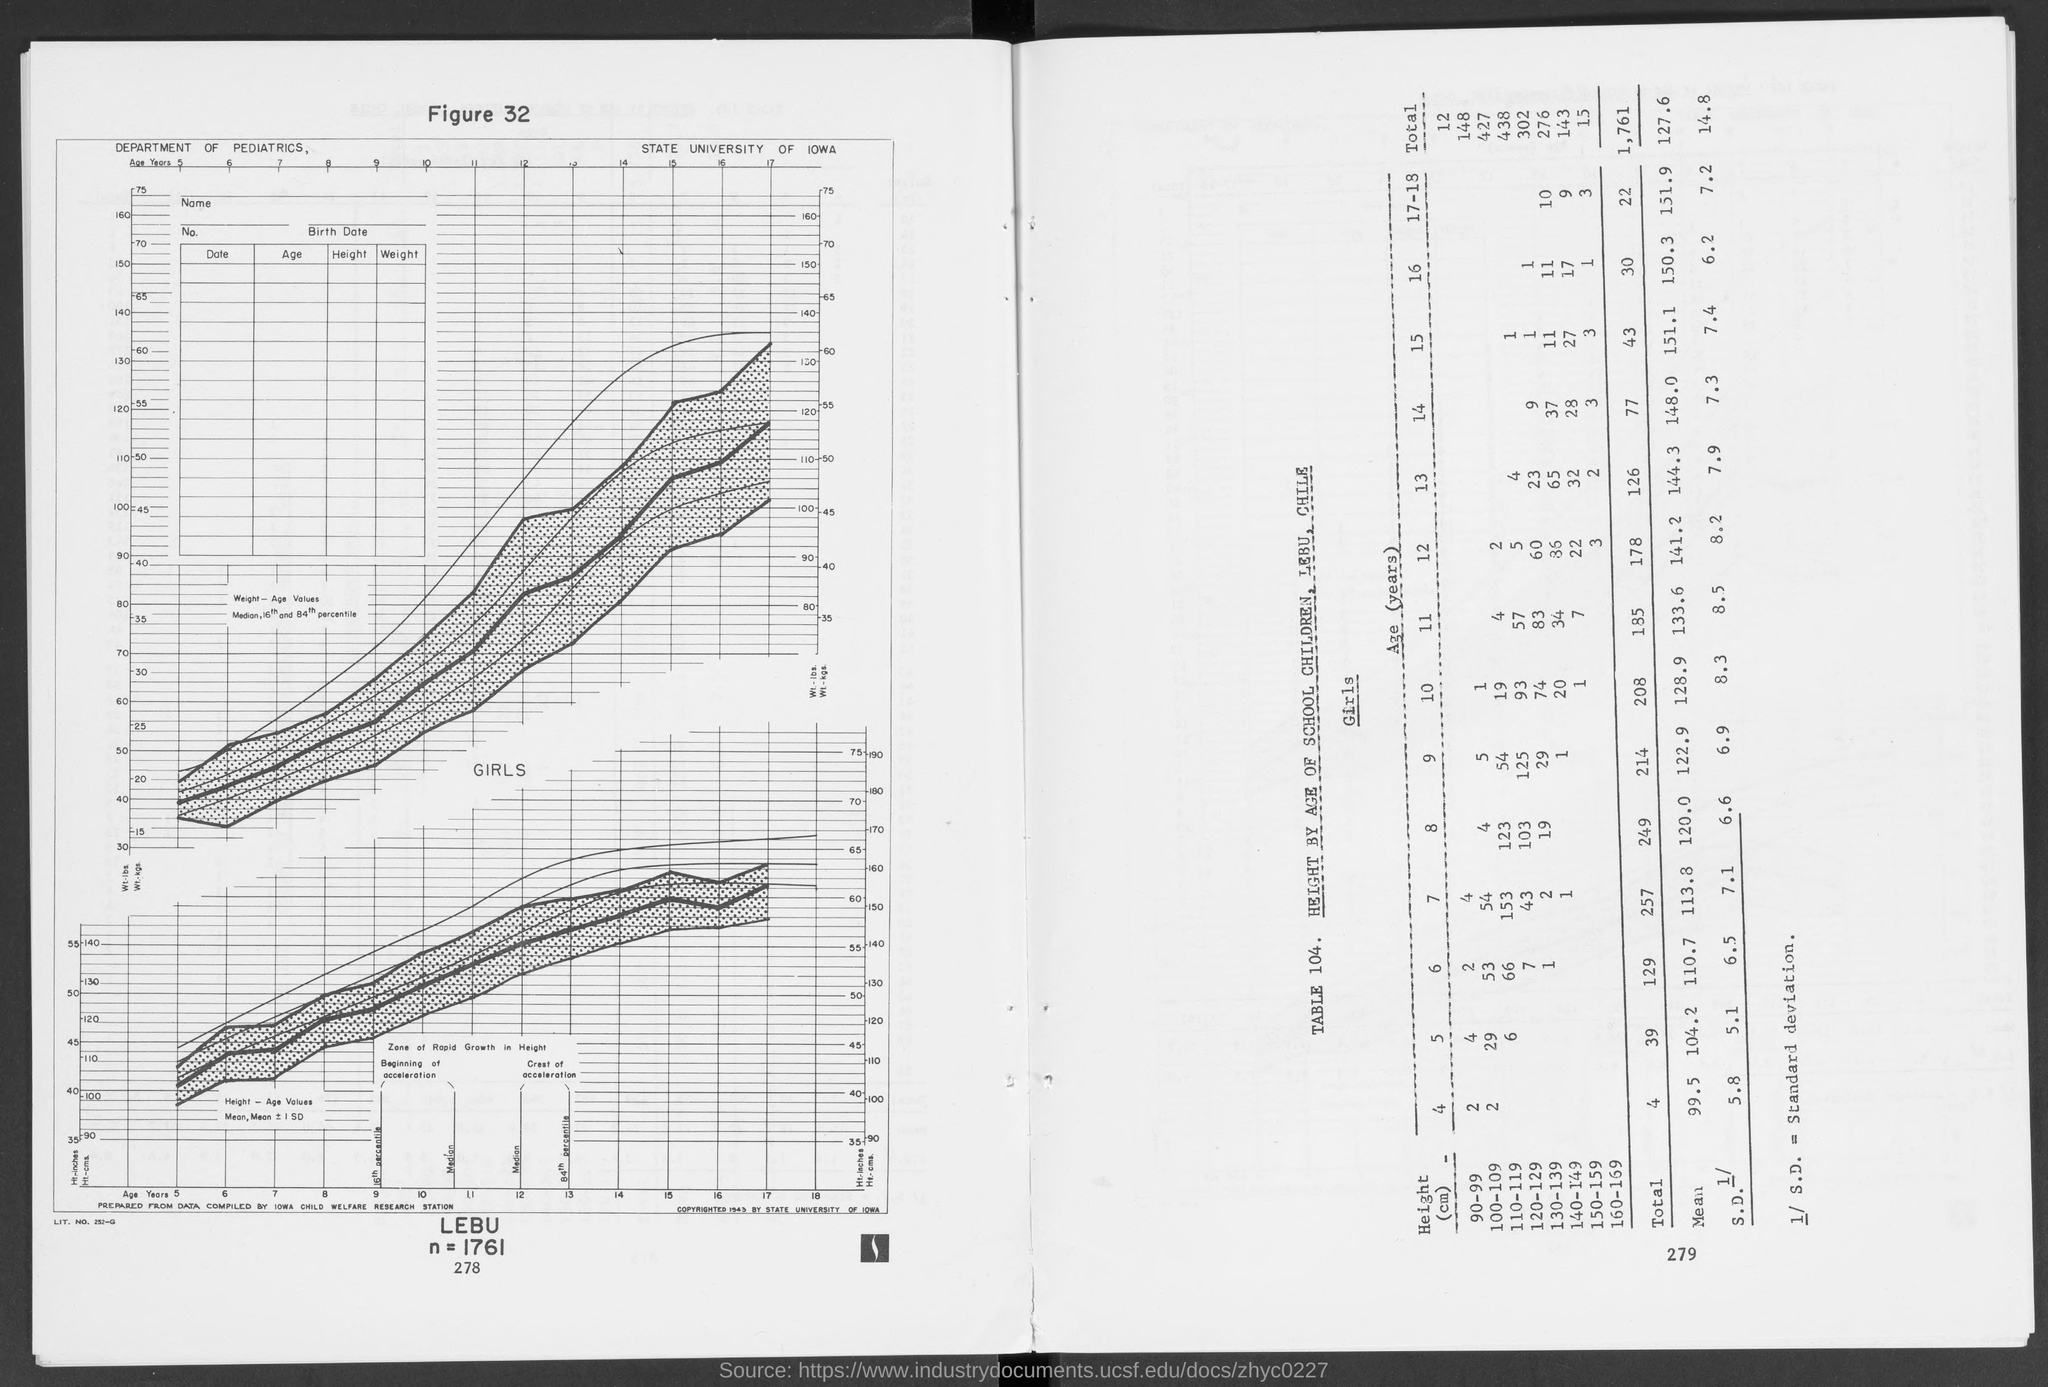What is the title of table 104?
Provide a succinct answer. Height by age of school children, lebu, chile. 